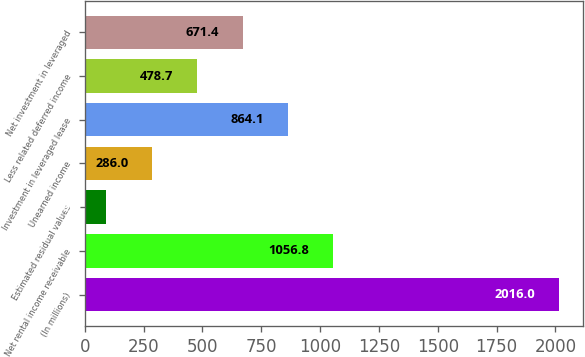<chart> <loc_0><loc_0><loc_500><loc_500><bar_chart><fcel>(In millions)<fcel>Net rental income receivable<fcel>Estimated residual values<fcel>Unearned income<fcel>Investment in leveraged lease<fcel>Less related deferred income<fcel>Net investment in leveraged<nl><fcel>2016<fcel>1056.8<fcel>89<fcel>286<fcel>864.1<fcel>478.7<fcel>671.4<nl></chart> 